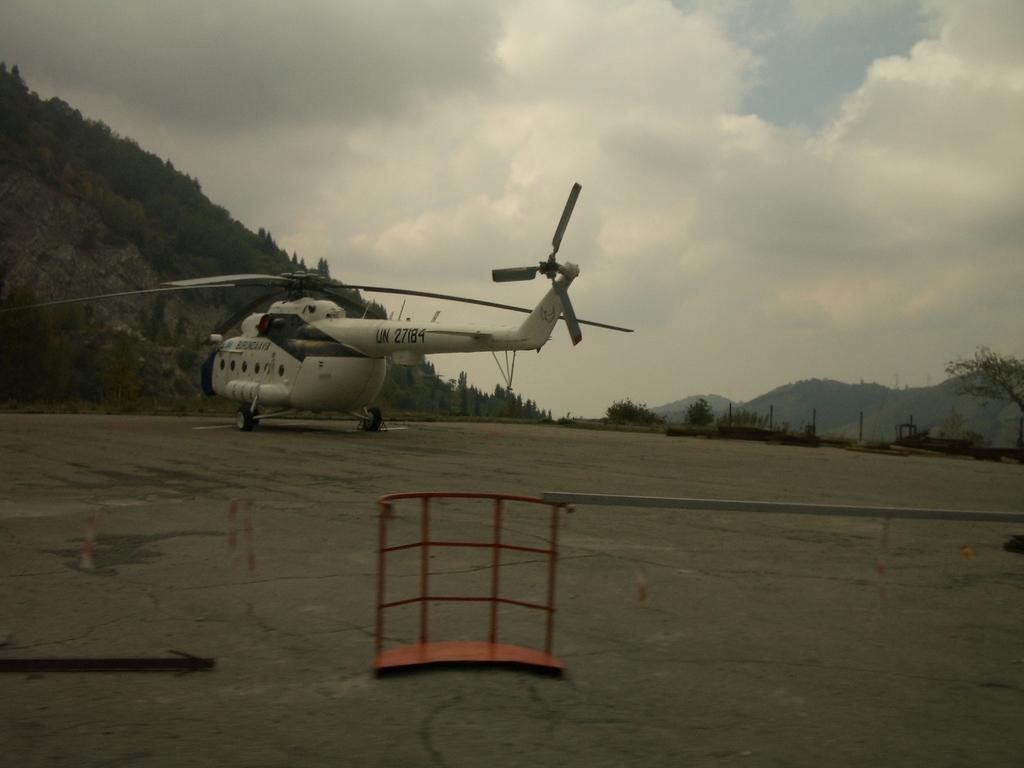What is the main subject of the image? The main subject of the image is a helicopter on the ground. What color is the prominent object in the image? There is a red color object in the image. What can be seen in the background of the image? There are mountains, trees, and the sky visible in the background of the image. Where is the nest of the birds in the image? There is no nest of birds present in the image. What type of music can be heard playing in the background of the image? There is no music present in the image; it is a still photograph. 